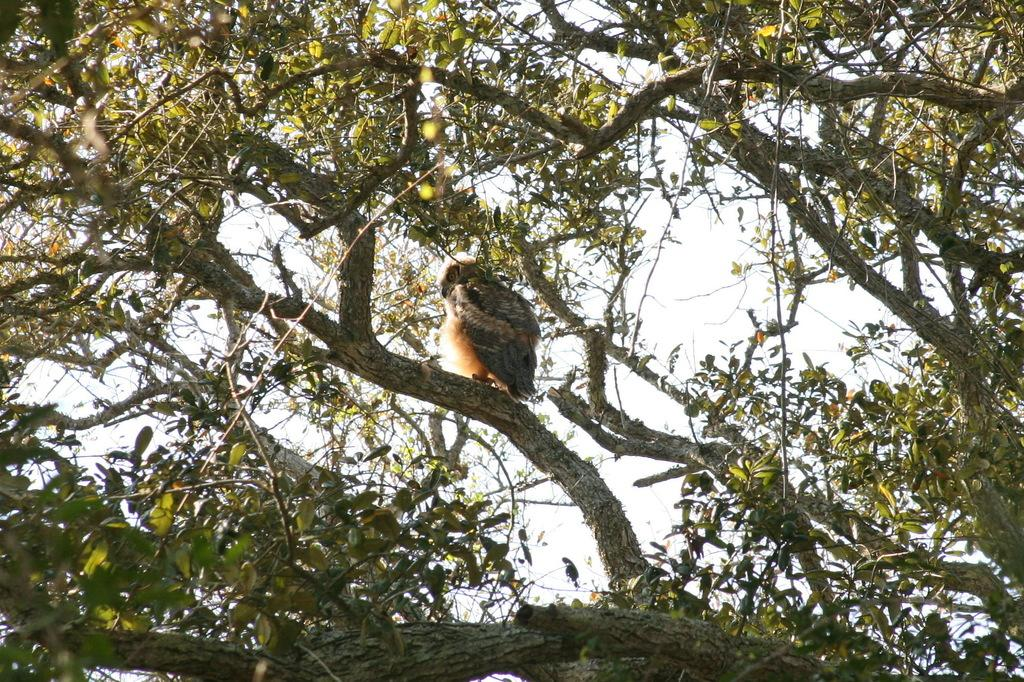What type of animal can be seen in the image? There is a bird in the image. Where is the bird located? The bird is on the branch of a tree. What can be seen in the background of the image? The sky is visible in the background of the image. What type of instrument is the bird playing in the image? There is no instrument present in the image, and the bird is not playing any instrument. 